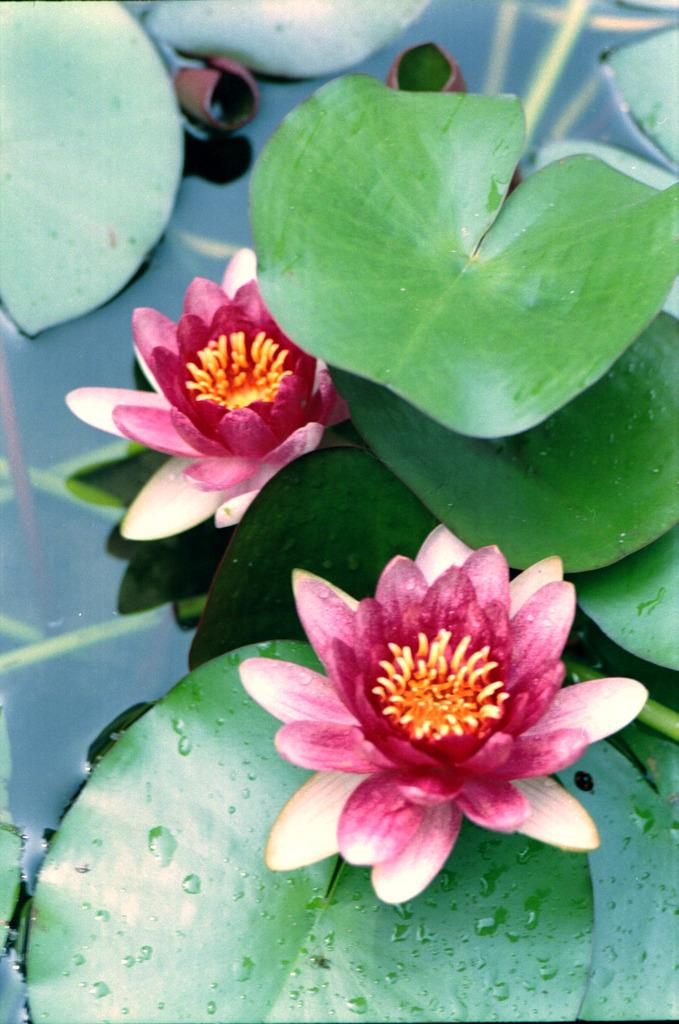What type of flowers are in the image? There are lotus flowers in the image. Where are the lotus flowers located? The lotus flowers are in a pond. What else can be seen in the image besides the lotus flowers? There are leaves in the image. Can you see a tiger eating bread in the image? No, there is no tiger or bread present in the image. 